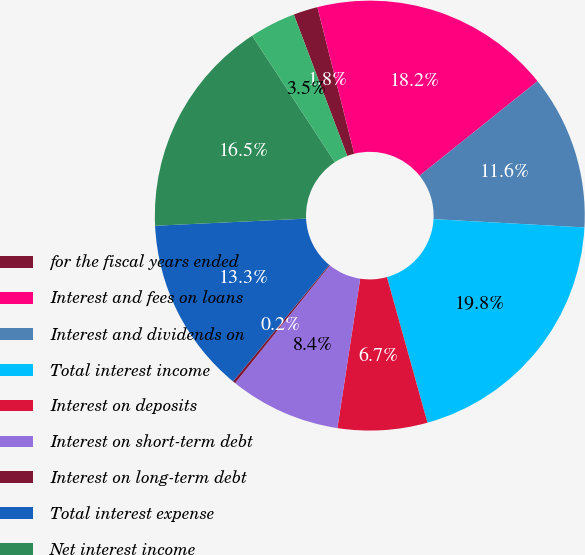Convert chart to OTSL. <chart><loc_0><loc_0><loc_500><loc_500><pie_chart><fcel>for the fiscal years ended<fcel>Interest and fees on loans<fcel>Interest and dividends on<fcel>Total interest income<fcel>Interest on deposits<fcel>Interest on short-term debt<fcel>Interest on long-term debt<fcel>Total interest expense<fcel>Net interest income<fcel>Unrealized gains (losses) on<nl><fcel>1.83%<fcel>18.17%<fcel>11.63%<fcel>19.8%<fcel>6.73%<fcel>8.37%<fcel>0.2%<fcel>13.27%<fcel>16.53%<fcel>3.47%<nl></chart> 